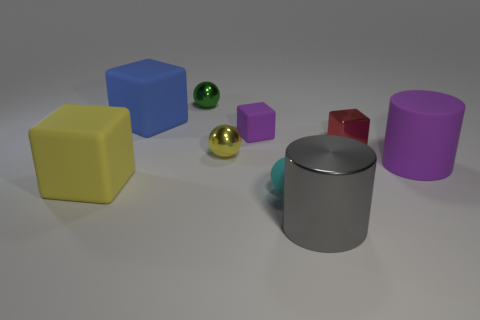Could you suggest a potential use for these objects? These objects could potentially be used as educational tools for teaching geometry and color recognition. The various shapes and colors can help learners differentiate between geometric figures and learn their properties. Additionally, they could be used in a creative setting, such as a child's playroom, for imaginative play and building structures. 